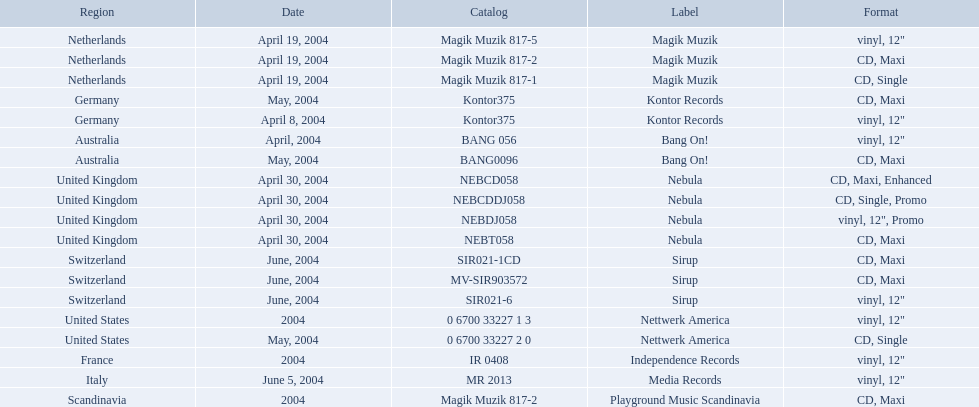Can you give me this table as a dict? {'header': ['Region', 'Date', 'Catalog', 'Label', 'Format'], 'rows': [['Netherlands', 'April 19, 2004', 'Magik Muzik 817-5', 'Magik Muzik', 'vinyl, 12"'], ['Netherlands', 'April 19, 2004', 'Magik Muzik 817-2', 'Magik Muzik', 'CD, Maxi'], ['Netherlands', 'April 19, 2004', 'Magik Muzik 817-1', 'Magik Muzik', 'CD, Single'], ['Germany', 'May, 2004', 'Kontor375', 'Kontor Records', 'CD, Maxi'], ['Germany', 'April 8, 2004', 'Kontor375', 'Kontor Records', 'vinyl, 12"'], ['Australia', 'April, 2004', 'BANG 056', 'Bang On!', 'vinyl, 12"'], ['Australia', 'May, 2004', 'BANG0096', 'Bang On!', 'CD, Maxi'], ['United Kingdom', 'April 30, 2004', 'NEBCD058', 'Nebula', 'CD, Maxi, Enhanced'], ['United Kingdom', 'April 30, 2004', 'NEBCDDJ058', 'Nebula', 'CD, Single, Promo'], ['United Kingdom', 'April 30, 2004', 'NEBDJ058', 'Nebula', 'vinyl, 12", Promo'], ['United Kingdom', 'April 30, 2004', 'NEBT058', 'Nebula', 'CD, Maxi'], ['Switzerland', 'June, 2004', 'SIR021-1CD', 'Sirup', 'CD, Maxi'], ['Switzerland', 'June, 2004', 'MV-SIR903572', 'Sirup', 'CD, Maxi'], ['Switzerland', 'June, 2004', 'SIR021-6', 'Sirup', 'vinyl, 12"'], ['United States', '2004', '0 6700 33227 1 3', 'Nettwerk America', 'vinyl, 12"'], ['United States', 'May, 2004', '0 6700 33227 2 0', 'Nettwerk America', 'CD, Single'], ['France', '2004', 'IR 0408', 'Independence Records', 'vinyl, 12"'], ['Italy', 'June 5, 2004', 'MR 2013', 'Media Records', 'vinyl, 12"'], ['Scandinavia', '2004', 'Magik Muzik 817-2', 'Playground Music Scandinavia', 'CD, Maxi']]} What are all of the regions the title was released in? Netherlands, Netherlands, Netherlands, Germany, Germany, Australia, Australia, United Kingdom, United Kingdom, United Kingdom, United Kingdom, Switzerland, Switzerland, Switzerland, United States, United States, France, Italy, Scandinavia. And under which labels were they released? Magik Muzik, Magik Muzik, Magik Muzik, Kontor Records, Kontor Records, Bang On!, Bang On!, Nebula, Nebula, Nebula, Nebula, Sirup, Sirup, Sirup, Nettwerk America, Nettwerk America, Independence Records, Media Records, Playground Music Scandinavia. Which label released the song in france? Independence Records. 